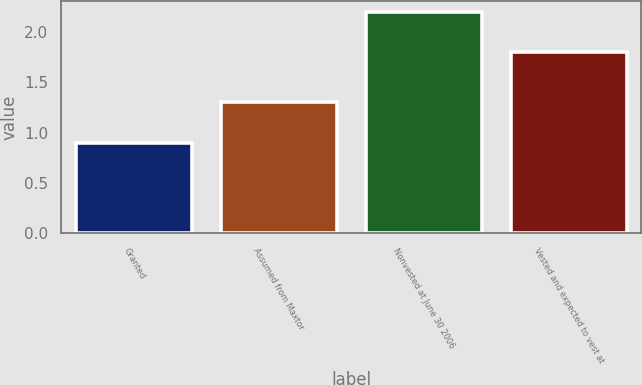Convert chart to OTSL. <chart><loc_0><loc_0><loc_500><loc_500><bar_chart><fcel>Granted<fcel>Assumed from Maxtor<fcel>Nonvested at June 30 2006<fcel>Vested and expected to vest at<nl><fcel>0.9<fcel>1.3<fcel>2.2<fcel>1.8<nl></chart> 